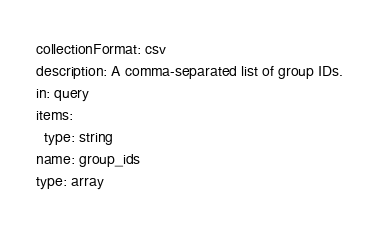<code> <loc_0><loc_0><loc_500><loc_500><_YAML_>collectionFormat: csv
description: A comma-separated list of group IDs.
in: query
items:
  type: string
name: group_ids
type: array
</code> 